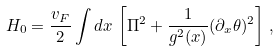Convert formula to latex. <formula><loc_0><loc_0><loc_500><loc_500>H _ { 0 } = \frac { v _ { F } } { 2 } \int d x \, \left [ \Pi ^ { 2 } + \frac { 1 } { g ^ { 2 } ( x ) } ( \partial _ { x } \theta ) ^ { 2 } \right ] \, ,</formula> 